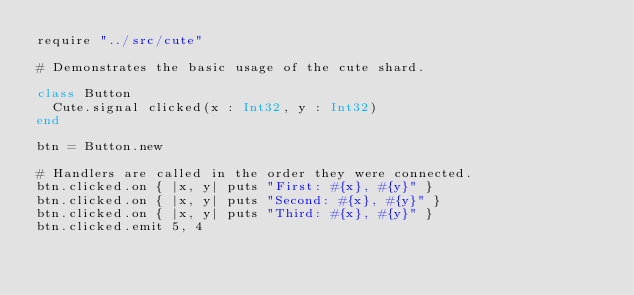Convert code to text. <code><loc_0><loc_0><loc_500><loc_500><_Crystal_>require "../src/cute"

# Demonstrates the basic usage of the cute shard.

class Button
  Cute.signal clicked(x : Int32, y : Int32)
end

btn = Button.new

# Handlers are called in the order they were connected.
btn.clicked.on { |x, y| puts "First: #{x}, #{y}" }
btn.clicked.on { |x, y| puts "Second: #{x}, #{y}" }
btn.clicked.on { |x, y| puts "Third: #{x}, #{y}" }
btn.clicked.emit 5, 4
</code> 